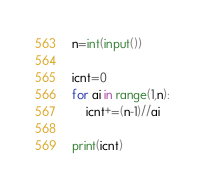Convert code to text. <code><loc_0><loc_0><loc_500><loc_500><_Python_>
n=int(input())

icnt=0
for ai in range(1,n):
    icnt+=(n-1)//ai
    
print(icnt)
</code> 